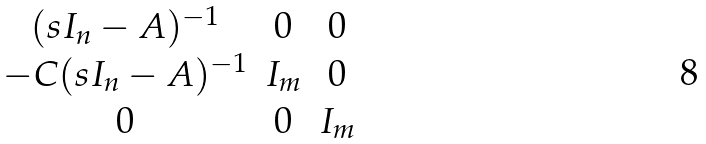<formula> <loc_0><loc_0><loc_500><loc_500>\begin{matrix} ( s I _ { n } - A ) ^ { - 1 } & 0 & 0 \\ - C ( s I _ { n } - A ) ^ { - 1 } & I _ { m } & 0 \\ 0 & 0 & I _ { m } \end{matrix}</formula> 